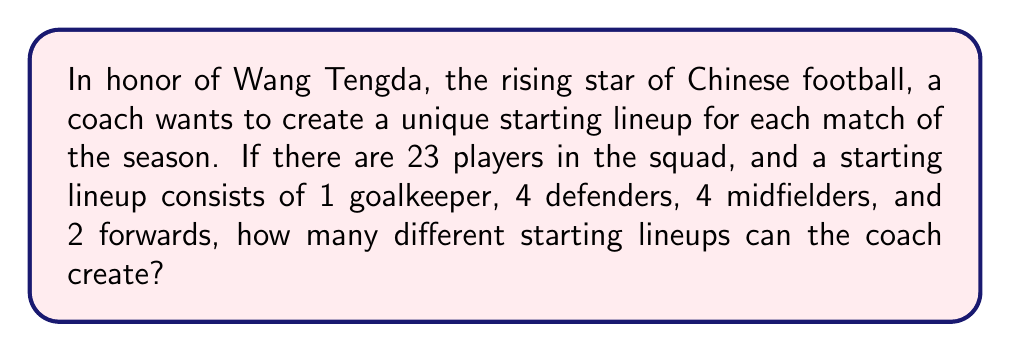Solve this math problem. Let's approach this step-by-step:

1) First, we need to choose 1 goalkeeper out of the available goalkeepers. Let's assume there are 3 goalkeepers in the squad. So we have:

   $${3 \choose 1} = 3$$ ways to choose the goalkeeper.

2) Next, we need to choose 4 defenders. Assuming there are 8 defenders in the squad:

   $${8 \choose 4} = 70$$ ways to choose the defenders.

3) For the midfielders, let's assume there are 8 midfielders in the squad. We need to choose 4:

   $${8 \choose 4} = 70$$ ways to choose the midfielders.

4) Finally, for the forwards, assuming there are 4 forwards in the squad, we need to choose 2:

   $${4 \choose 2} = 6$$ ways to choose the forwards.

5) By the multiplication principle, the total number of possible lineups is the product of these individual choices:

   $$3 \times 70 \times 70 \times 6 = 88,200$$

Therefore, the coach can create 88,200 different starting lineups.
Answer: 88,200 